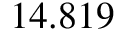<formula> <loc_0><loc_0><loc_500><loc_500>1 4 . 8 1 9 \</formula> 